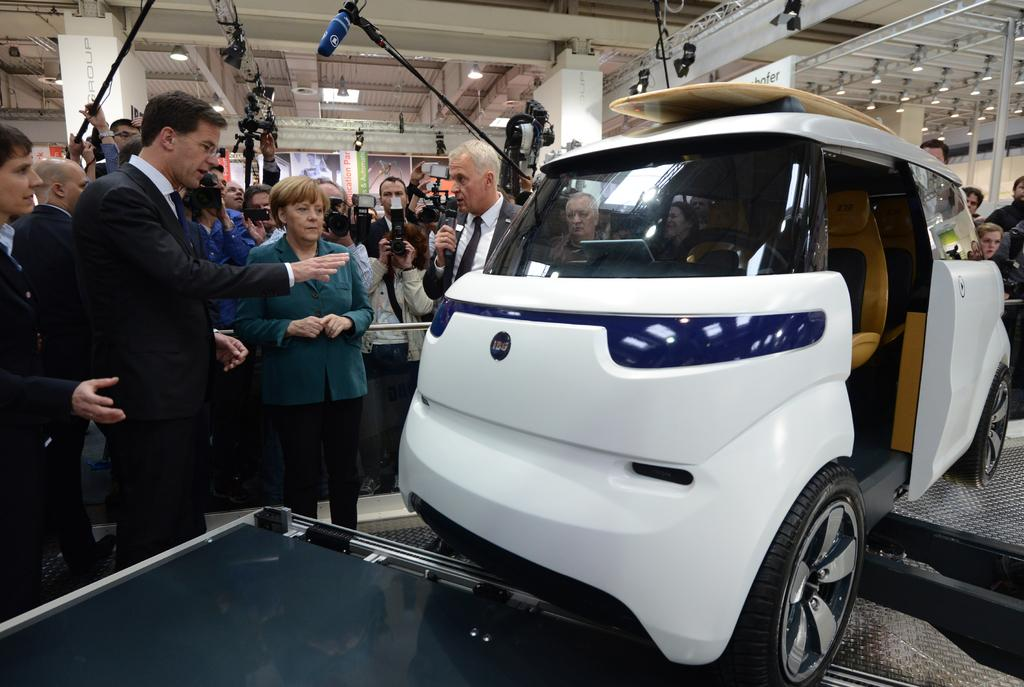What is the main subject of the image? The main subject of the image is a car. What are the people in the image doing? The people are standing behind the car and holding cameras and mics. What type of print can be seen on the rail in the image? There is no rail or print present in the image. What government-related activity is taking place in the image? There is no indication of any government-related activity in the image. 